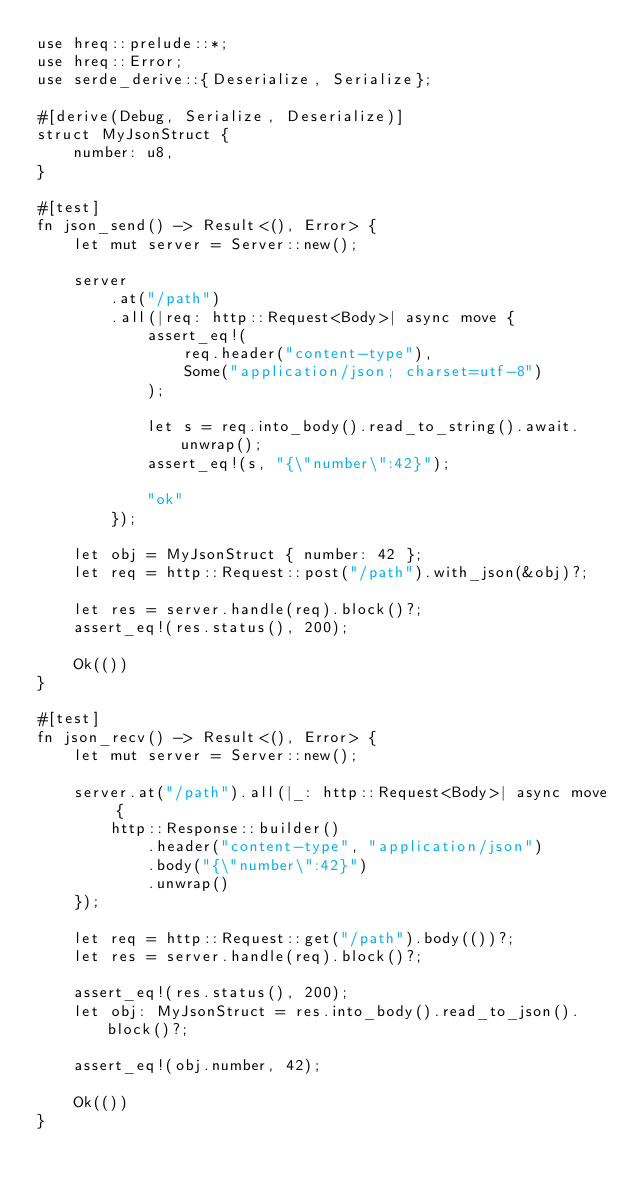Convert code to text. <code><loc_0><loc_0><loc_500><loc_500><_Rust_>use hreq::prelude::*;
use hreq::Error;
use serde_derive::{Deserialize, Serialize};

#[derive(Debug, Serialize, Deserialize)]
struct MyJsonStruct {
    number: u8,
}

#[test]
fn json_send() -> Result<(), Error> {
    let mut server = Server::new();

    server
        .at("/path")
        .all(|req: http::Request<Body>| async move {
            assert_eq!(
                req.header("content-type"),
                Some("application/json; charset=utf-8")
            );

            let s = req.into_body().read_to_string().await.unwrap();
            assert_eq!(s, "{\"number\":42}");

            "ok"
        });

    let obj = MyJsonStruct { number: 42 };
    let req = http::Request::post("/path").with_json(&obj)?;

    let res = server.handle(req).block()?;
    assert_eq!(res.status(), 200);

    Ok(())
}

#[test]
fn json_recv() -> Result<(), Error> {
    let mut server = Server::new();

    server.at("/path").all(|_: http::Request<Body>| async move {
        http::Response::builder()
            .header("content-type", "application/json")
            .body("{\"number\":42}")
            .unwrap()
    });

    let req = http::Request::get("/path").body(())?;
    let res = server.handle(req).block()?;

    assert_eq!(res.status(), 200);
    let obj: MyJsonStruct = res.into_body().read_to_json().block()?;

    assert_eq!(obj.number, 42);

    Ok(())
}
</code> 